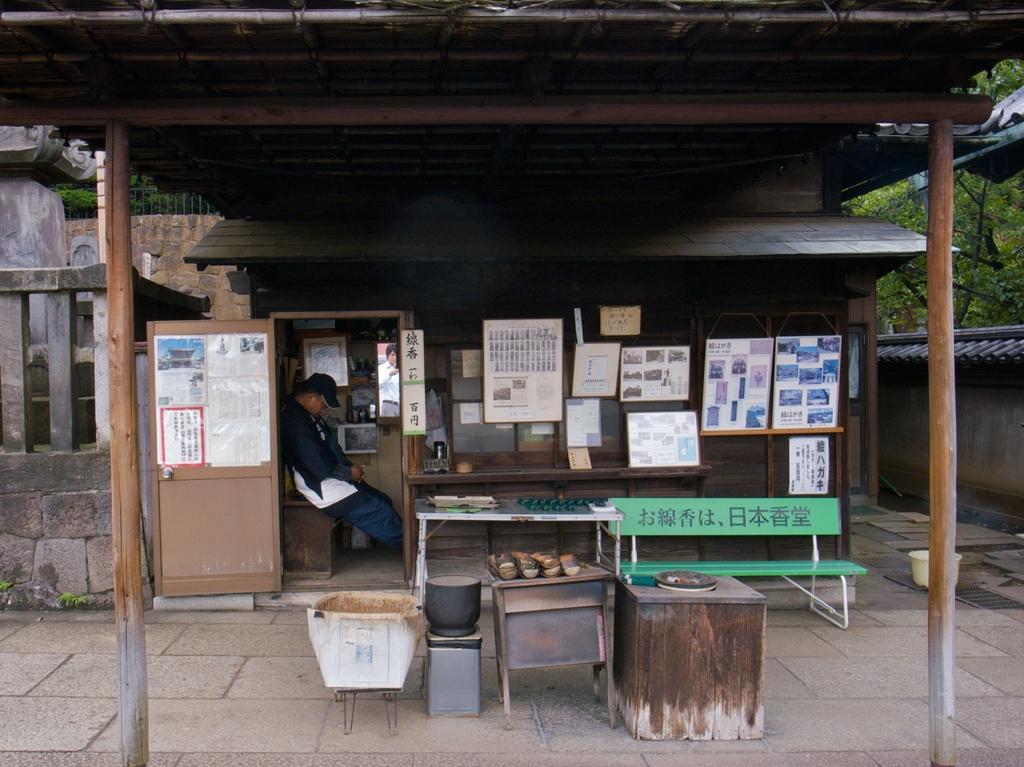In one or two sentences, can you explain what this image depicts? This picture shows a House and we see a man seated on a table and we see few posts on the wall of the house and a bench 